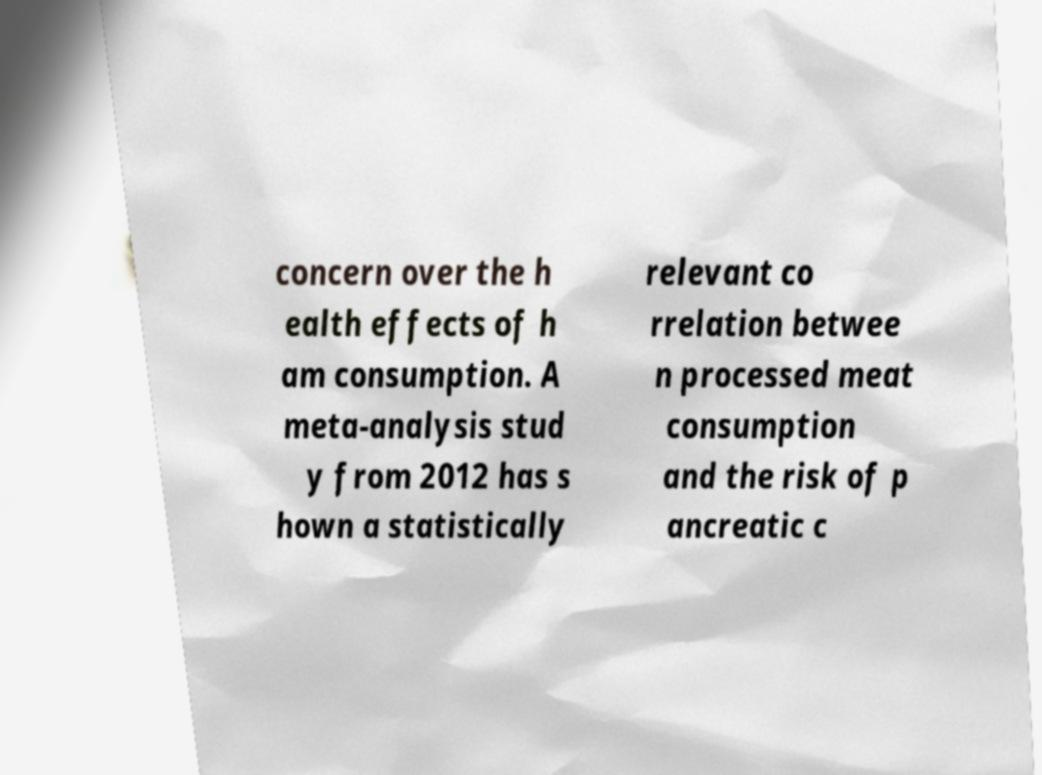Can you accurately transcribe the text from the provided image for me? concern over the h ealth effects of h am consumption. A meta-analysis stud y from 2012 has s hown a statistically relevant co rrelation betwee n processed meat consumption and the risk of p ancreatic c 